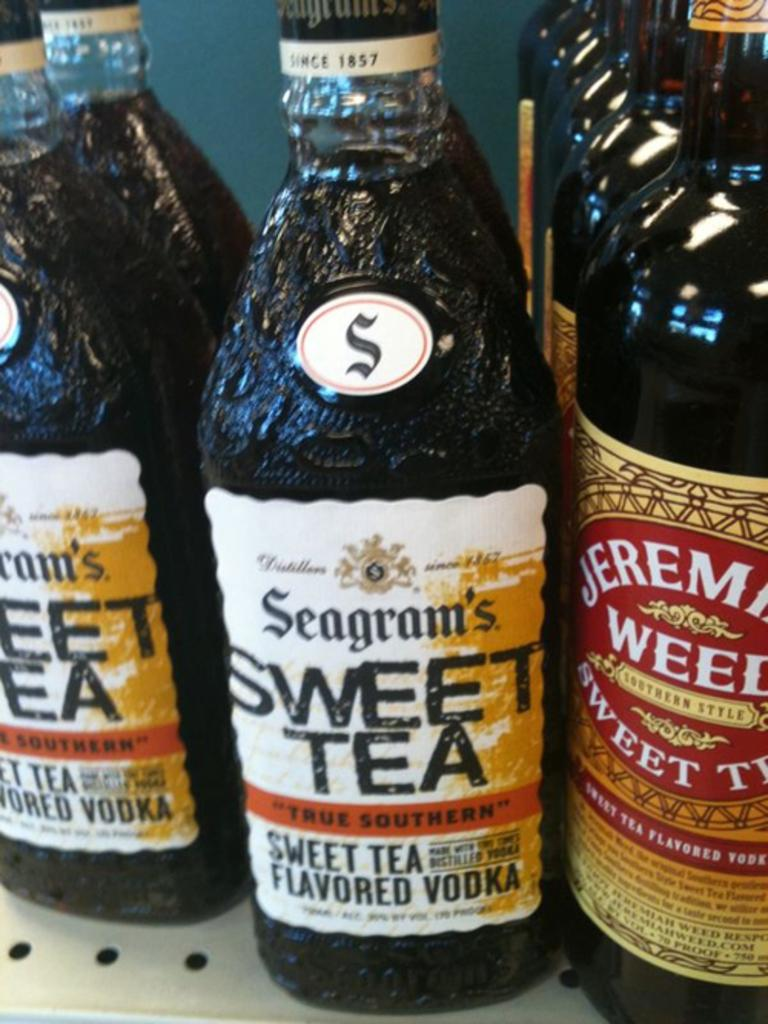<image>
Relay a brief, clear account of the picture shown. Some bottles of vodka, which say that they are sweet tea flavored. 